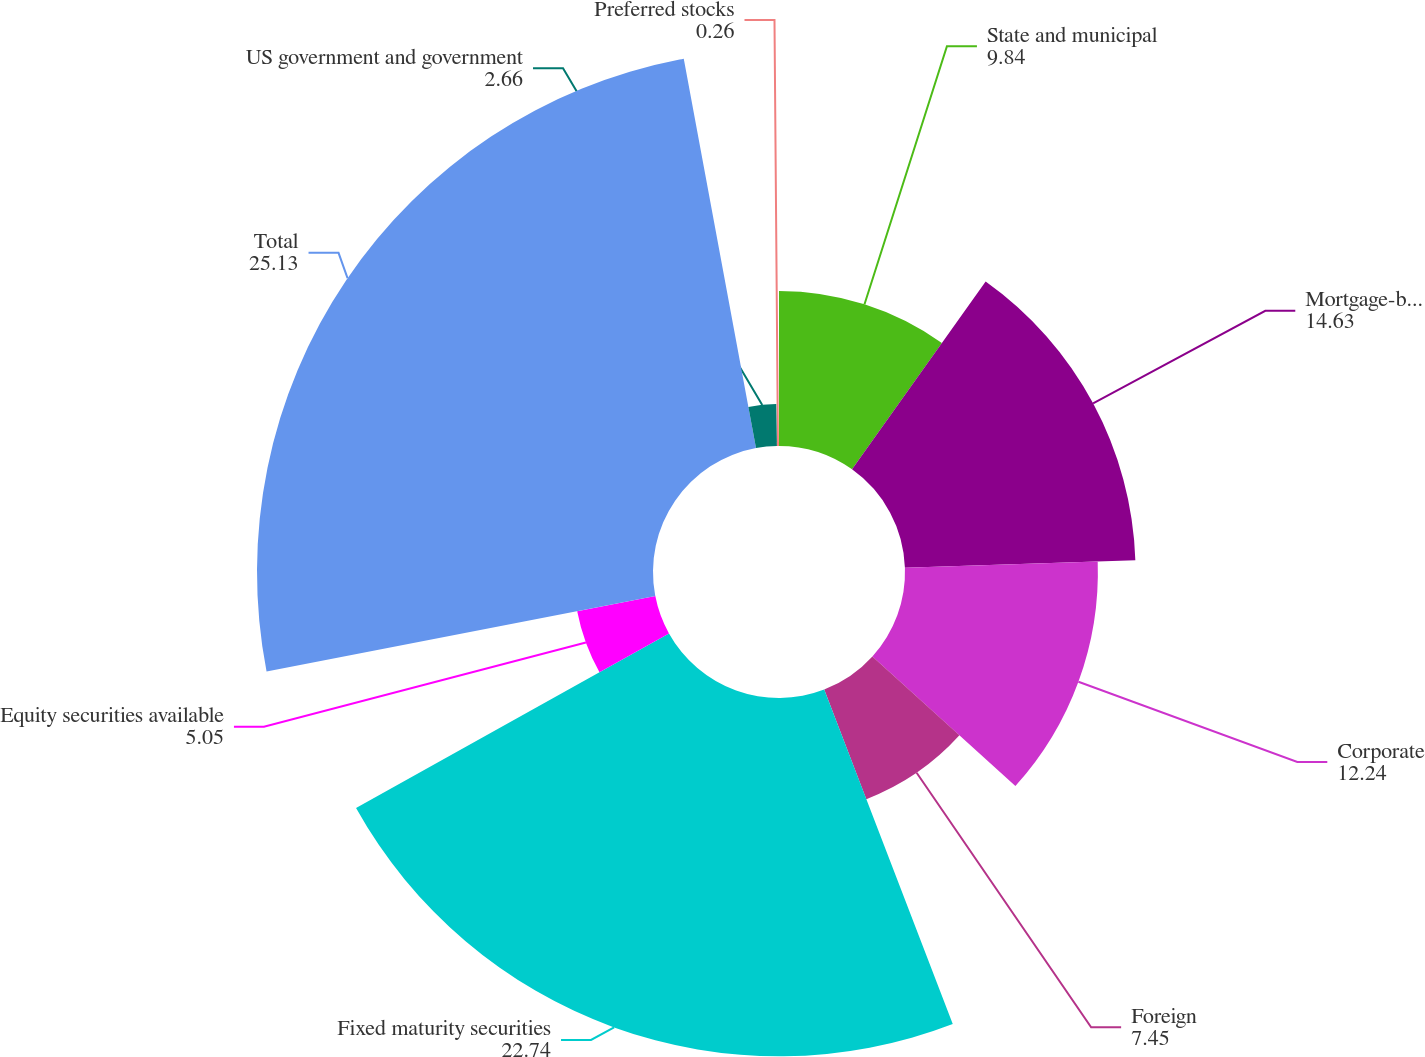<chart> <loc_0><loc_0><loc_500><loc_500><pie_chart><fcel>State and municipal<fcel>Mortgage-backed securities<fcel>Corporate<fcel>Foreign<fcel>Fixed maturity securities<fcel>Equity securities available<fcel>Total<fcel>US government and government<fcel>Preferred stocks<nl><fcel>9.84%<fcel>14.63%<fcel>12.24%<fcel>7.45%<fcel>22.74%<fcel>5.05%<fcel>25.13%<fcel>2.66%<fcel>0.26%<nl></chart> 